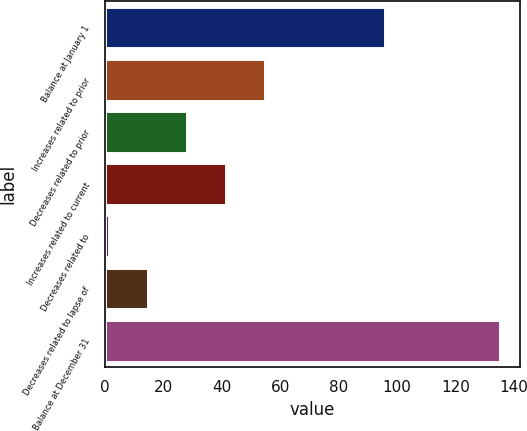Convert chart to OTSL. <chart><loc_0><loc_0><loc_500><loc_500><bar_chart><fcel>Balance at January 1<fcel>Increases related to prior<fcel>Decreases related to prior<fcel>Increases related to current<fcel>Decreases related to<fcel>Decreases related to lapse of<fcel>Balance at December 31<nl><fcel>95.7<fcel>54.86<fcel>28.08<fcel>41.47<fcel>1.3<fcel>14.69<fcel>135.2<nl></chart> 